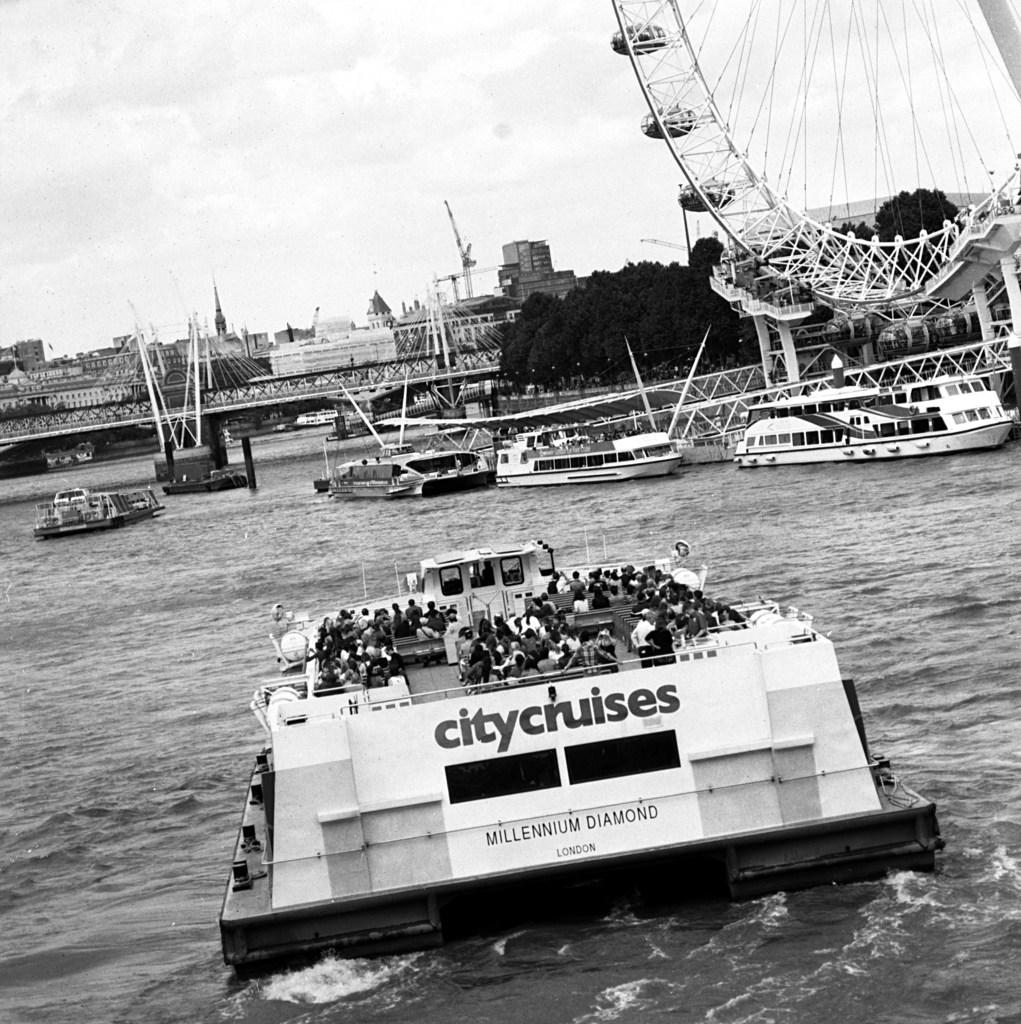<image>
Write a terse but informative summary of the picture. A City Cruises boat has a large number of people on the top deck. 